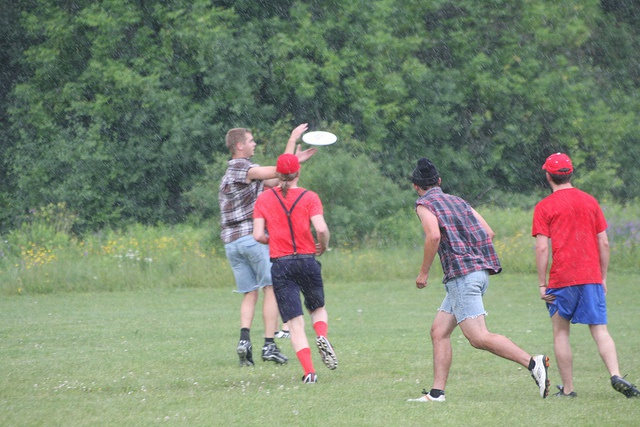Describe the objects in this image and their specific colors. I can see people in black, red, salmon, darkgray, and lightpink tones, people in black, darkgray, lightpink, gray, and lavender tones, people in black, salmon, gray, darkgray, and pink tones, people in black, darkgray, gray, and pink tones, and frisbee in black, white, darkgray, and gray tones in this image. 